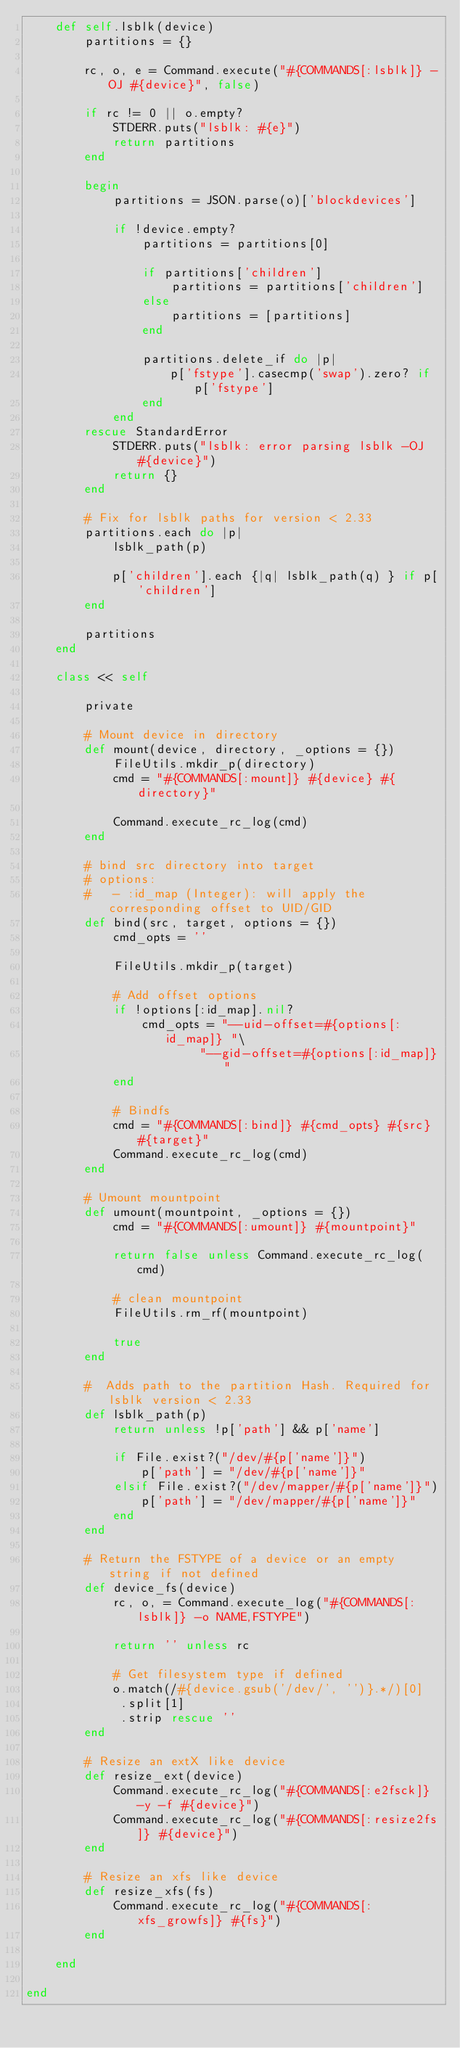<code> <loc_0><loc_0><loc_500><loc_500><_Ruby_>    def self.lsblk(device)
        partitions = {}

        rc, o, e = Command.execute("#{COMMANDS[:lsblk]} -OJ #{device}", false)

        if rc != 0 || o.empty?
            STDERR.puts("lsblk: #{e}")
            return partitions
        end

        begin
            partitions = JSON.parse(o)['blockdevices']

            if !device.empty?
                partitions = partitions[0]

                if partitions['children']
                    partitions = partitions['children']
                else
                    partitions = [partitions]
                end

                partitions.delete_if do |p|
                    p['fstype'].casecmp('swap').zero? if p['fstype']
                end
            end
        rescue StandardError
            STDERR.puts("lsblk: error parsing lsblk -OJ #{device}")
            return {}
        end

        # Fix for lsblk paths for version < 2.33
        partitions.each do |p|
            lsblk_path(p)

            p['children'].each {|q| lsblk_path(q) } if p['children']
        end

        partitions
    end

    class << self

        private

        # Mount device in directory
        def mount(device, directory, _options = {})
            FileUtils.mkdir_p(directory)
            cmd = "#{COMMANDS[:mount]} #{device} #{directory}"

            Command.execute_rc_log(cmd)
        end

        # bind src directory into target
        # options:
        #   - :id_map (Integer): will apply the corresponding offset to UID/GID
        def bind(src, target, options = {})
            cmd_opts = ''

            FileUtils.mkdir_p(target)

            # Add offset options
            if !options[:id_map].nil?
                cmd_opts = "--uid-offset=#{options[:id_map]} "\
                        "--gid-offset=#{options[:id_map]}"
            end

            # Bindfs
            cmd = "#{COMMANDS[:bind]} #{cmd_opts} #{src} #{target}"
            Command.execute_rc_log(cmd)
        end

        # Umount mountpoint
        def umount(mountpoint, _options = {})
            cmd = "#{COMMANDS[:umount]} #{mountpoint}"

            return false unless Command.execute_rc_log(cmd)

            # clean mountpoint
            FileUtils.rm_rf(mountpoint)

            true
        end

        #  Adds path to the partition Hash. Required for lsblk version < 2.33
        def lsblk_path(p)
            return unless !p['path'] && p['name']

            if File.exist?("/dev/#{p['name']}")
                p['path'] = "/dev/#{p['name']}"
            elsif File.exist?("/dev/mapper/#{p['name']}")
                p['path'] = "/dev/mapper/#{p['name']}"
            end
        end

        # Return the FSTYPE of a device or an empty string if not defined
        def device_fs(device)
            rc, o, = Command.execute_log("#{COMMANDS[:lsblk]} -o NAME,FSTYPE")

            return '' unless rc

            # Get filesystem type if defined
            o.match(/#{device.gsub('/dev/', '')}.*/)[0]
             .split[1]
             .strip rescue ''
        end

        # Resize an extX like device
        def resize_ext(device)
            Command.execute_rc_log("#{COMMANDS[:e2fsck]} -y -f #{device}")
            Command.execute_rc_log("#{COMMANDS[:resize2fs]} #{device}")
        end

        # Resize an xfs like device
        def resize_xfs(fs)
            Command.execute_rc_log("#{COMMANDS[:xfs_growfs]} #{fs}")
        end

    end

end
</code> 